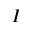<formula> <loc_0><loc_0><loc_500><loc_500>I</formula> 